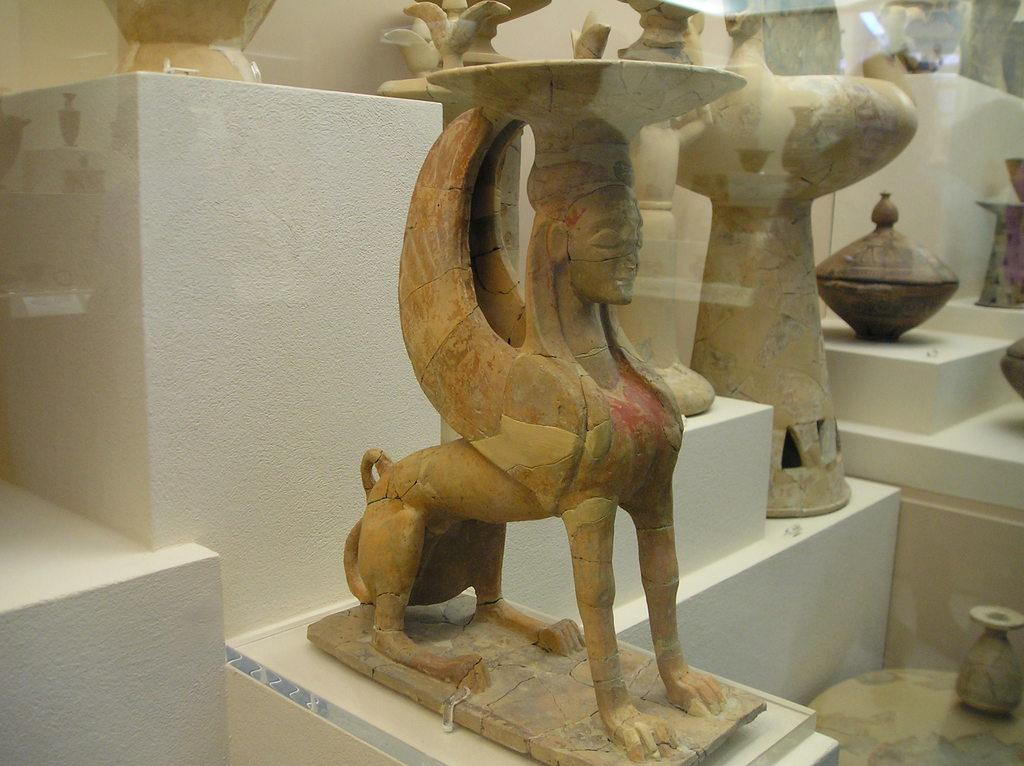What can be seen in the image? There are statues in the image. Where are the statues located? The statues are on concert-walls. What color are the concert-walls? The concert-walls are white in color. How many sticks can be seen in the image? There are no sticks present in the image. What type of spot is visible on the statues in the image? There are no spots visible on the statues in the image; they are smooth. 